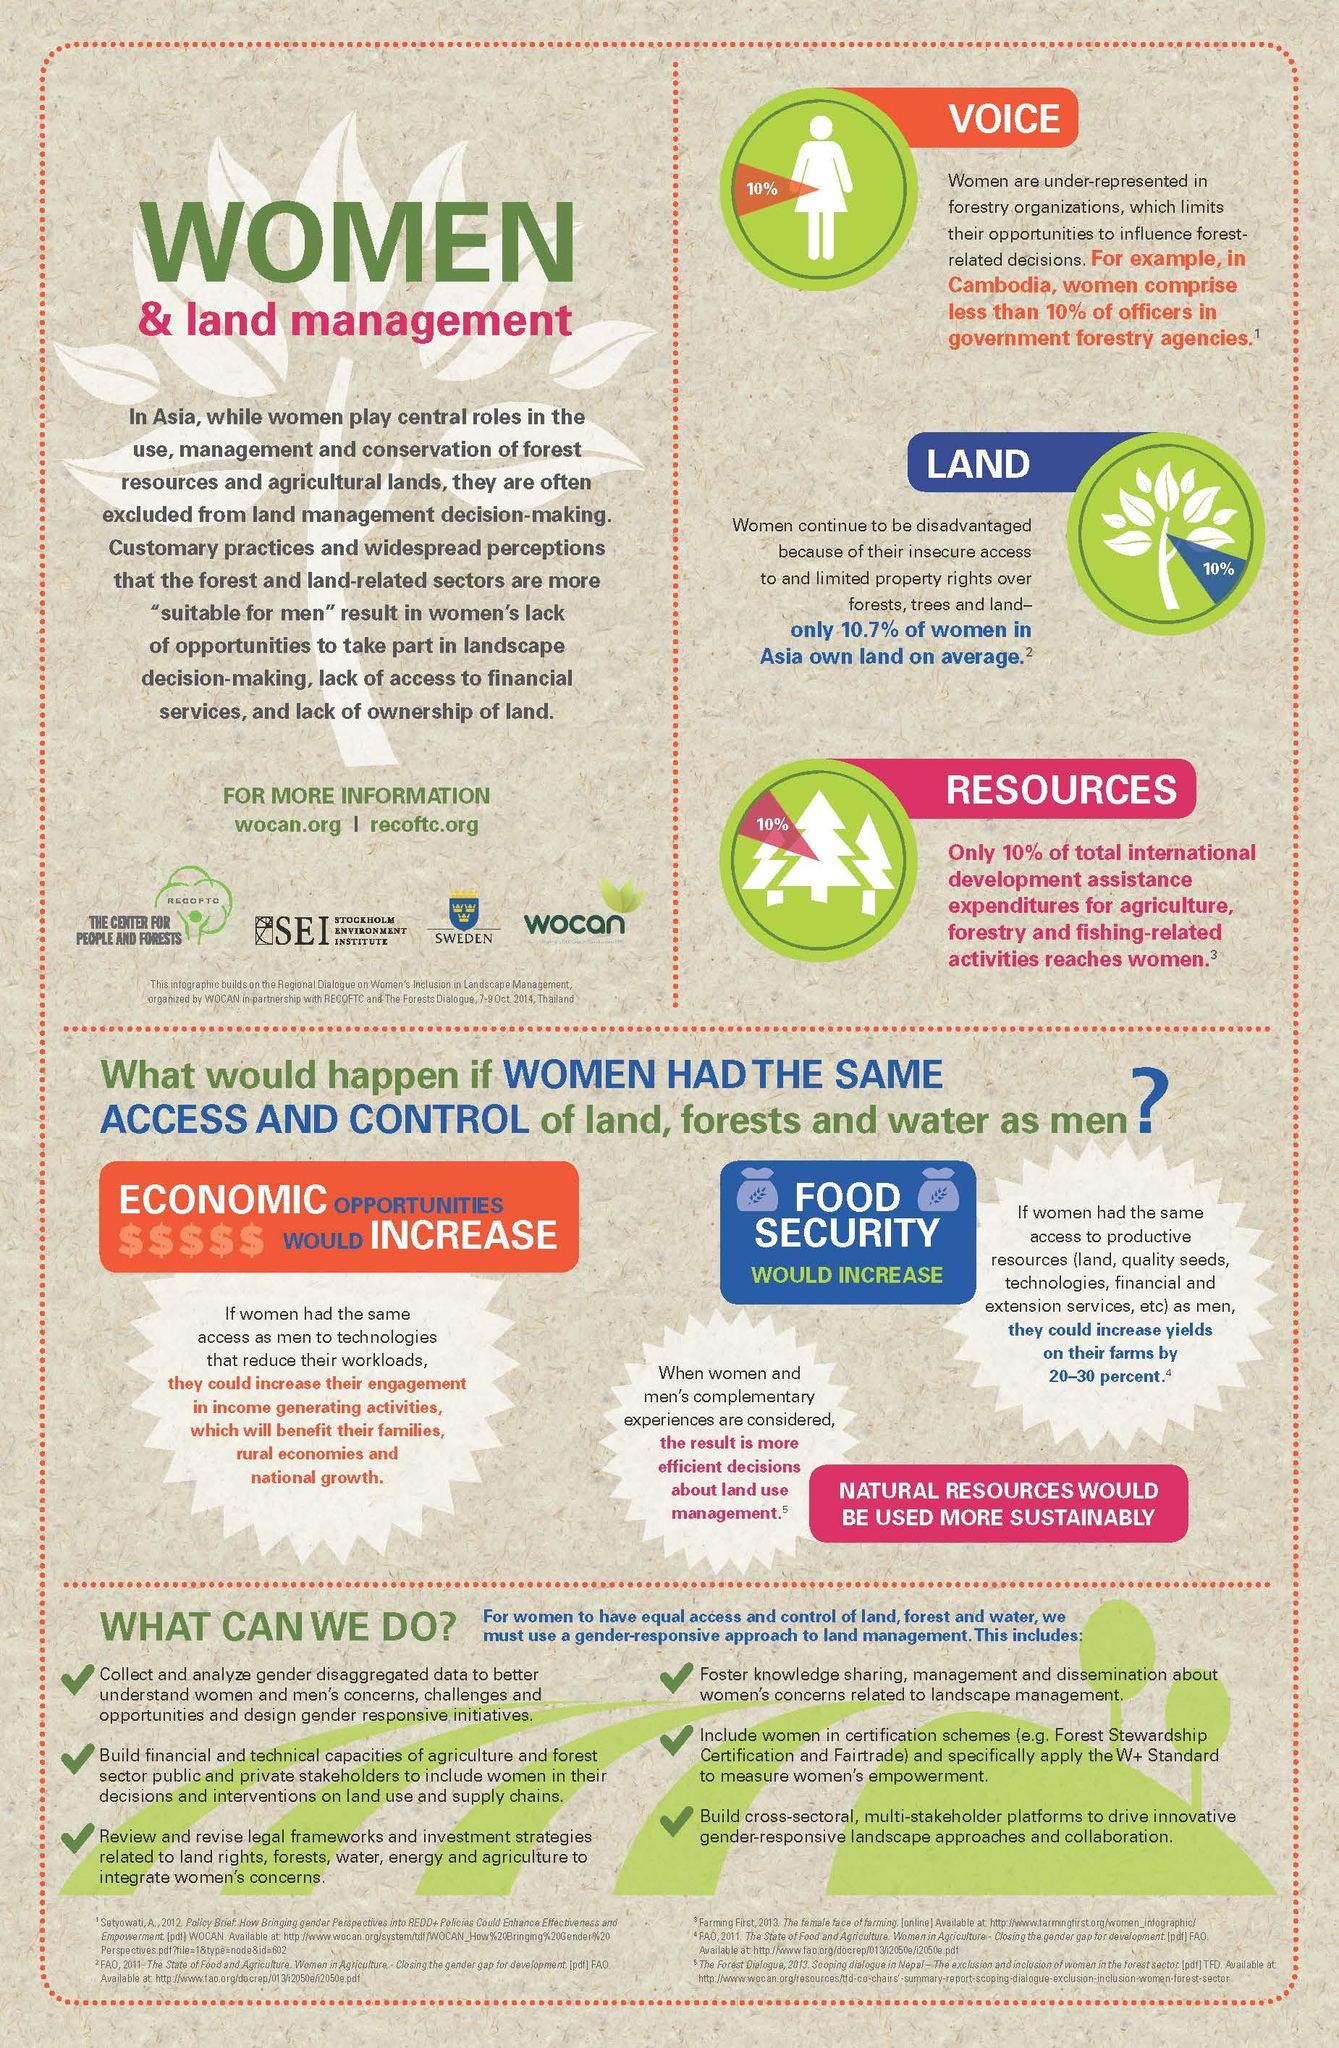Point out several critical features in this image. It is estimated that men own approximately 89.3% of the land in Asia. In Cambodia, it is estimated that approximately 90% of forest officers are male. 